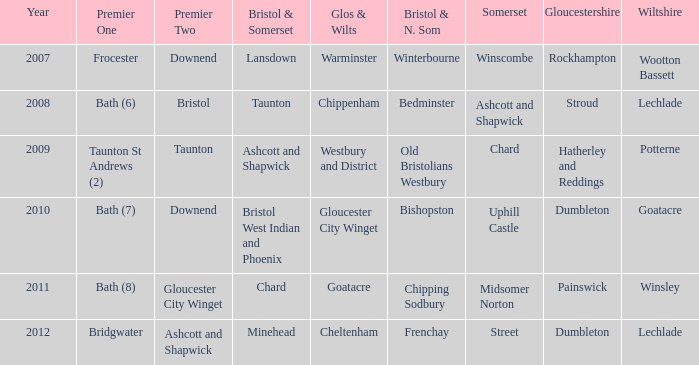What does the bristol & n. som refer to, specifically in the context of somerset's ashcott and shapwick? Bedminster. 